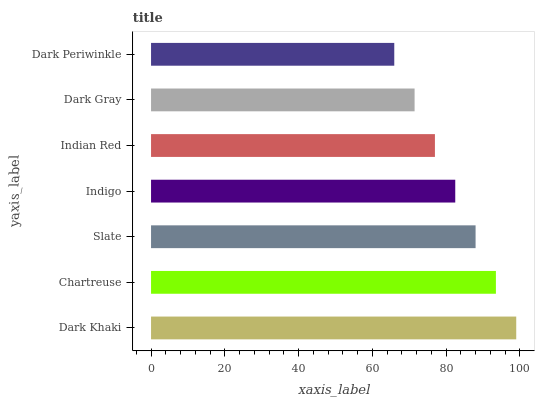Is Dark Periwinkle the minimum?
Answer yes or no. Yes. Is Dark Khaki the maximum?
Answer yes or no. Yes. Is Chartreuse the minimum?
Answer yes or no. No. Is Chartreuse the maximum?
Answer yes or no. No. Is Dark Khaki greater than Chartreuse?
Answer yes or no. Yes. Is Chartreuse less than Dark Khaki?
Answer yes or no. Yes. Is Chartreuse greater than Dark Khaki?
Answer yes or no. No. Is Dark Khaki less than Chartreuse?
Answer yes or no. No. Is Indigo the high median?
Answer yes or no. Yes. Is Indigo the low median?
Answer yes or no. Yes. Is Dark Gray the high median?
Answer yes or no. No. Is Chartreuse the low median?
Answer yes or no. No. 